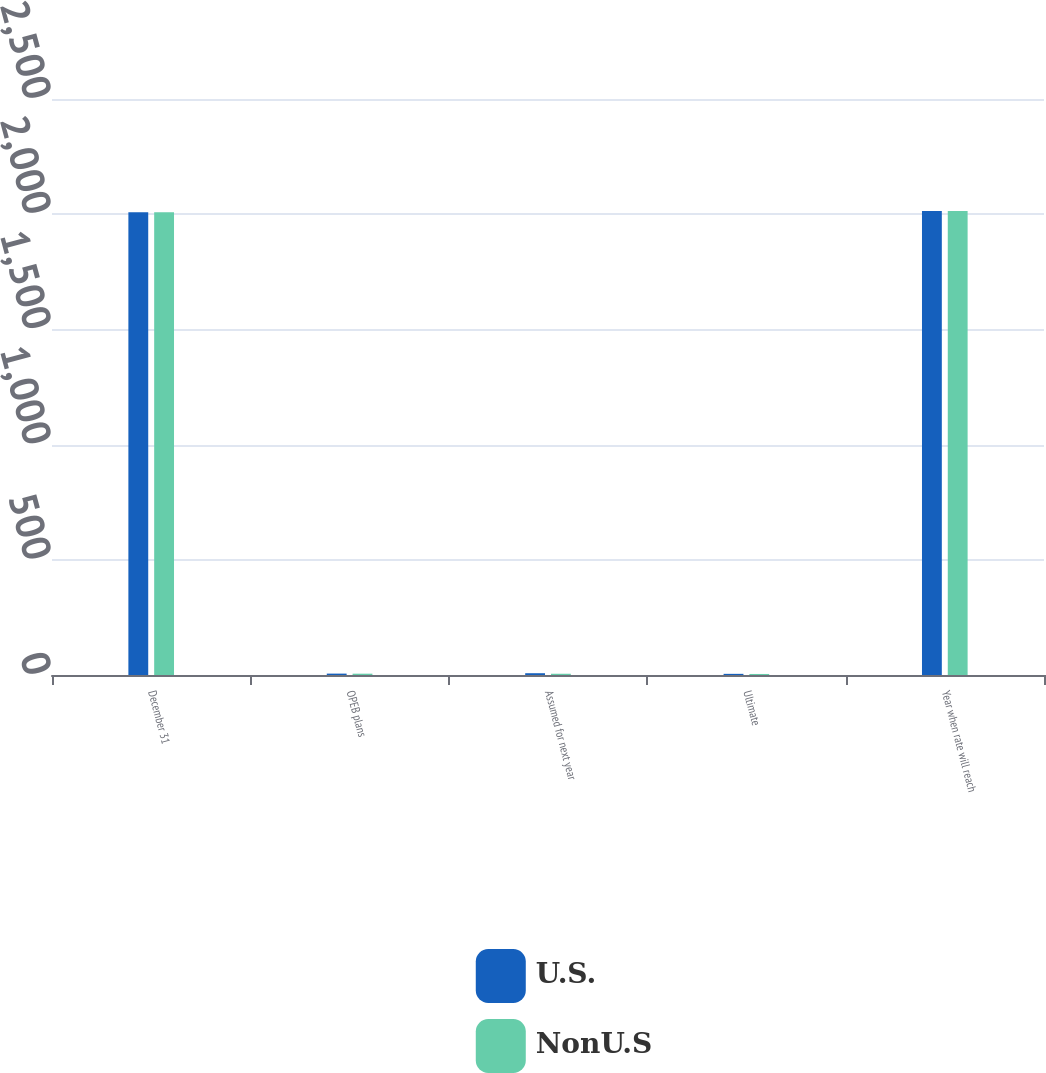Convert chart. <chart><loc_0><loc_0><loc_500><loc_500><stacked_bar_chart><ecel><fcel>December 31<fcel>OPEB plans<fcel>Assumed for next year<fcel>Ultimate<fcel>Year when rate will reach<nl><fcel>U.S.<fcel>2009<fcel>6<fcel>7.75<fcel>5<fcel>2014<nl><fcel>NonU.S<fcel>2009<fcel>5.7<fcel>5.4<fcel>4.5<fcel>2014<nl></chart> 